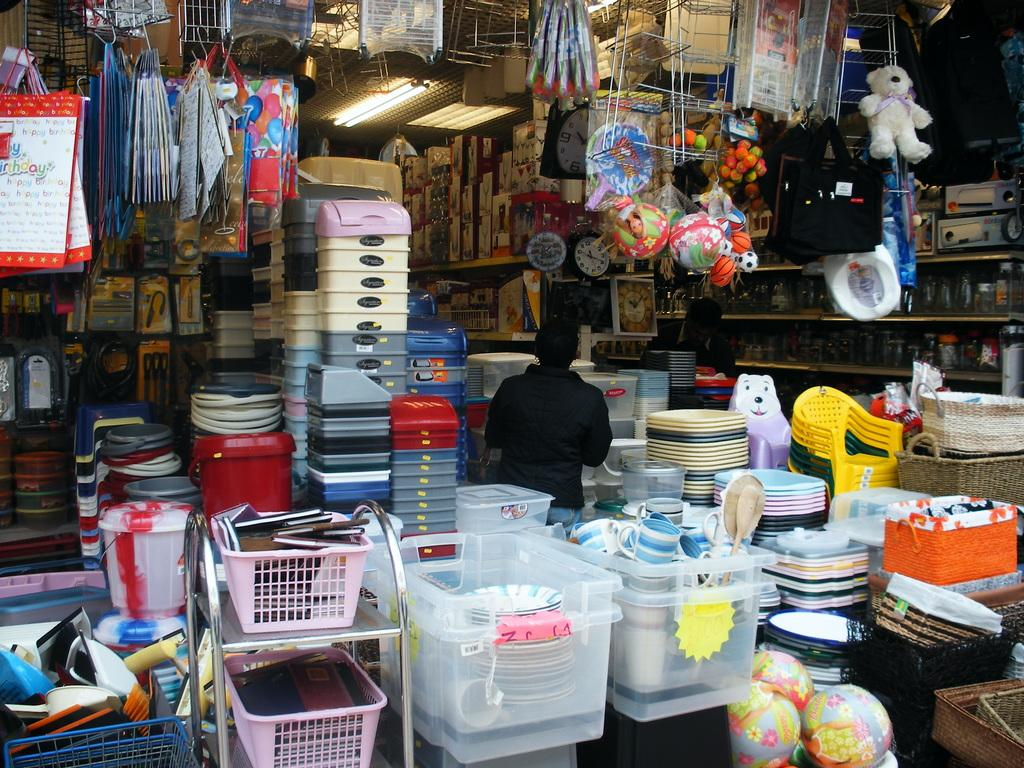Provide a one-sentence caption for the provided image. Various kinck nacks including bags that say Happy Birthday and balls labeled by Barbi. 